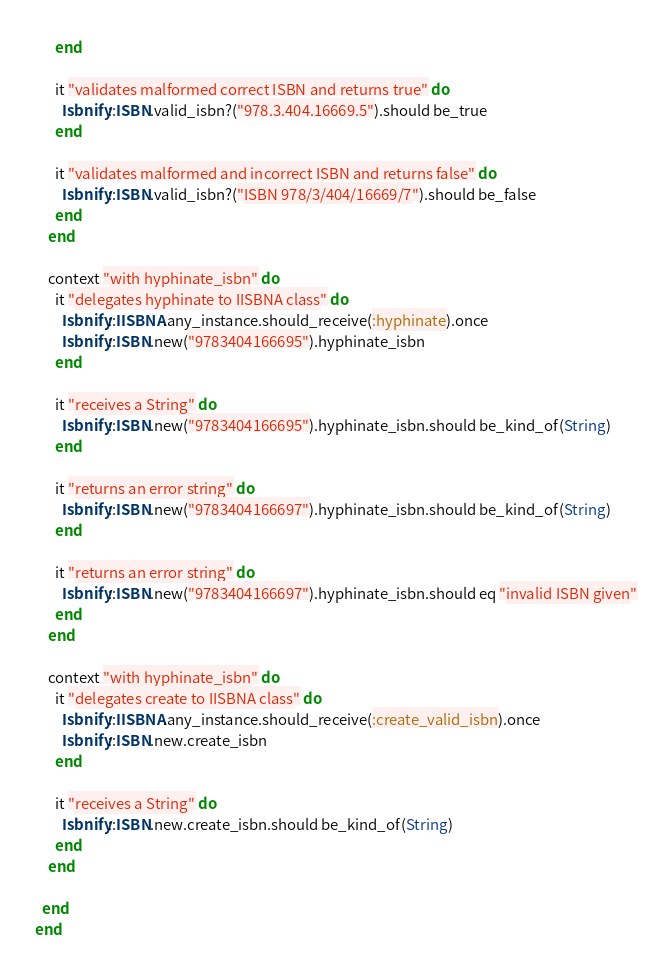<code> <loc_0><loc_0><loc_500><loc_500><_Ruby_>      end

      it "validates malformed correct ISBN and returns true" do
        Isbnify::ISBN.valid_isbn?("978.3.404.16669.5").should be_true
      end

      it "validates malformed and incorrect ISBN and returns false" do
        Isbnify::ISBN.valid_isbn?("ISBN 978/3/404/16669/7").should be_false
      end
    end

    context "with hyphinate_isbn" do
      it "delegates hyphinate to IISBNA class" do
        Isbnify::IISBNA.any_instance.should_receive(:hyphinate).once
        Isbnify::ISBN.new("9783404166695").hyphinate_isbn
      end

      it "receives a String" do
        Isbnify::ISBN.new("9783404166695").hyphinate_isbn.should be_kind_of(String)
      end

      it "returns an error string" do
        Isbnify::ISBN.new("9783404166697").hyphinate_isbn.should be_kind_of(String)
      end

      it "returns an error string" do
        Isbnify::ISBN.new("9783404166697").hyphinate_isbn.should eq "invalid ISBN given"
      end
    end

    context "with hyphinate_isbn" do
      it "delegates create to IISBNA class" do
        Isbnify::IISBNA.any_instance.should_receive(:create_valid_isbn).once
        Isbnify::ISBN.new.create_isbn
      end

      it "receives a String" do
        Isbnify::ISBN.new.create_isbn.should be_kind_of(String)
      end
    end

  end
end</code> 